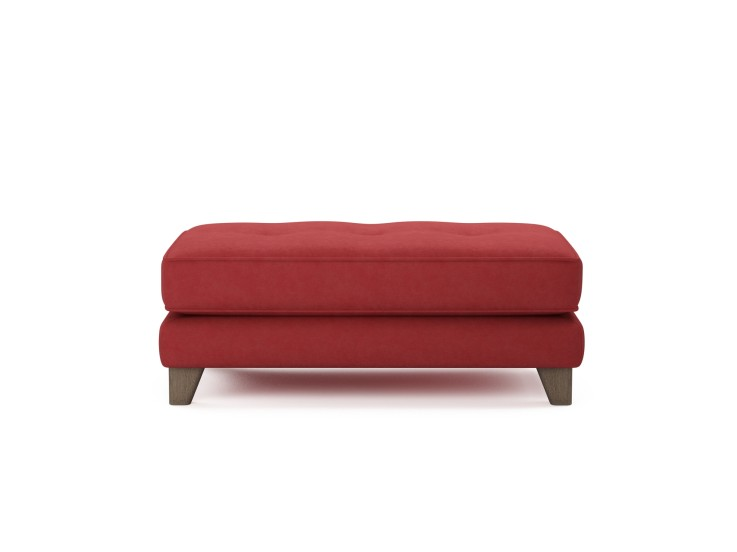How does the color of this ottoman influence the perception of space in a room? The vibrant red color of the ottoman can alter the perception of space by serving as a bold statement piece. In a room with muted colors, it can act as an eye-catching element that draws attention and adds depth, potentially making the room feel more dynamic and inviting. For smaller spaces, using such a bright color might energize the area without overwhelming it, if balanced correctly with neutral tones or minimalistic decor. 